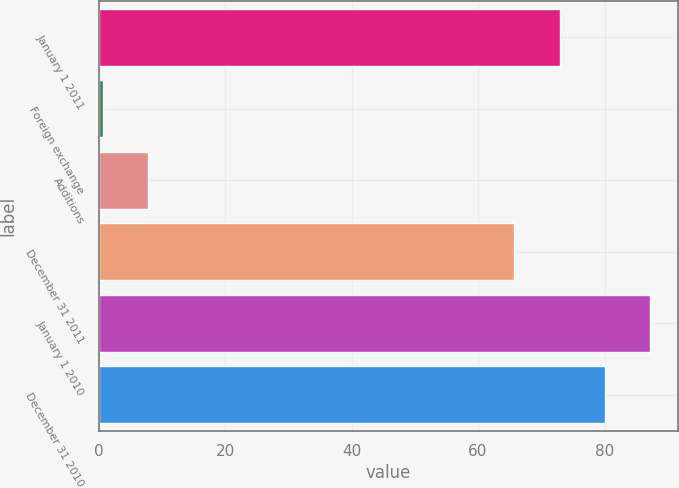Convert chart. <chart><loc_0><loc_0><loc_500><loc_500><bar_chart><fcel>January 1 2011<fcel>Foreign exchange<fcel>Additions<fcel>December 31 2011<fcel>January 1 2010<fcel>December 31 2010<nl><fcel>72.88<fcel>0.7<fcel>7.88<fcel>65.7<fcel>87.24<fcel>80.06<nl></chart> 